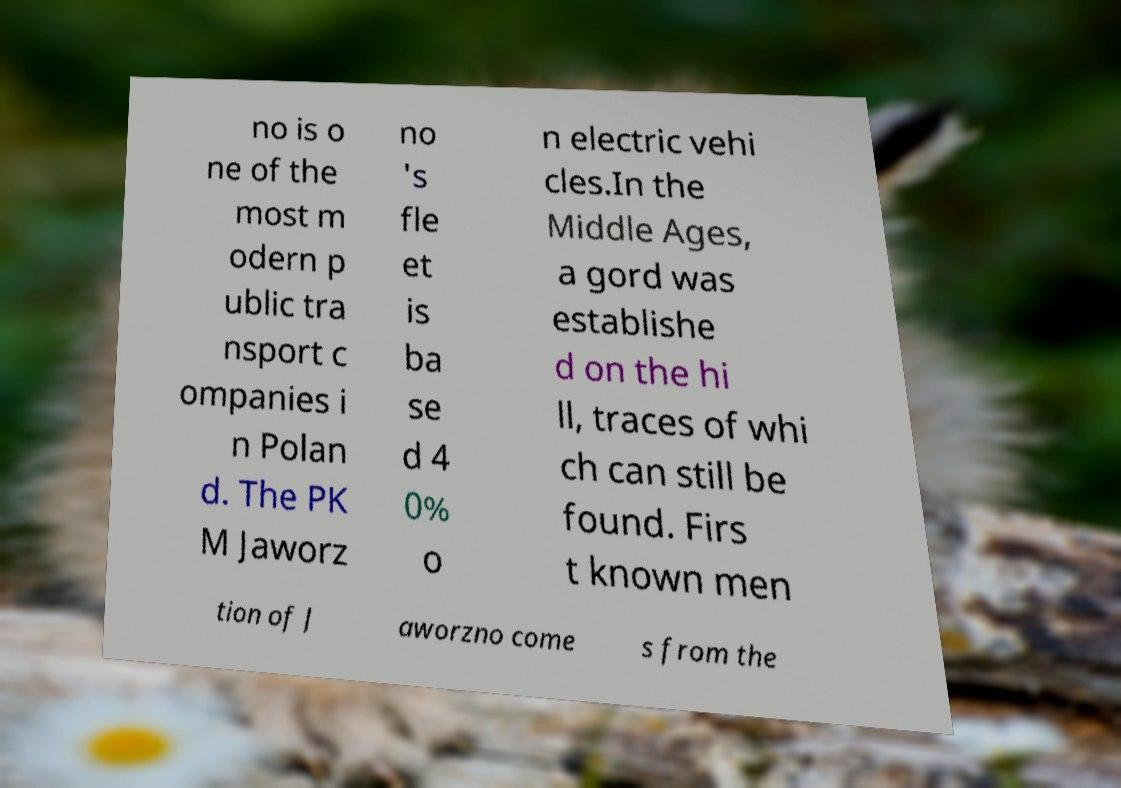Could you assist in decoding the text presented in this image and type it out clearly? no is o ne of the most m odern p ublic tra nsport c ompanies i n Polan d. The PK M Jaworz no 's fle et is ba se d 4 0% o n electric vehi cles.In the Middle Ages, a gord was establishe d on the hi ll, traces of whi ch can still be found. Firs t known men tion of J aworzno come s from the 